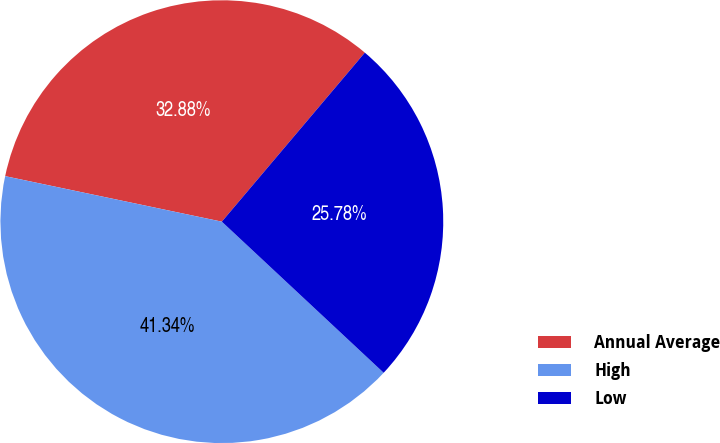<chart> <loc_0><loc_0><loc_500><loc_500><pie_chart><fcel>Annual Average<fcel>High<fcel>Low<nl><fcel>32.88%<fcel>41.34%<fcel>25.78%<nl></chart> 